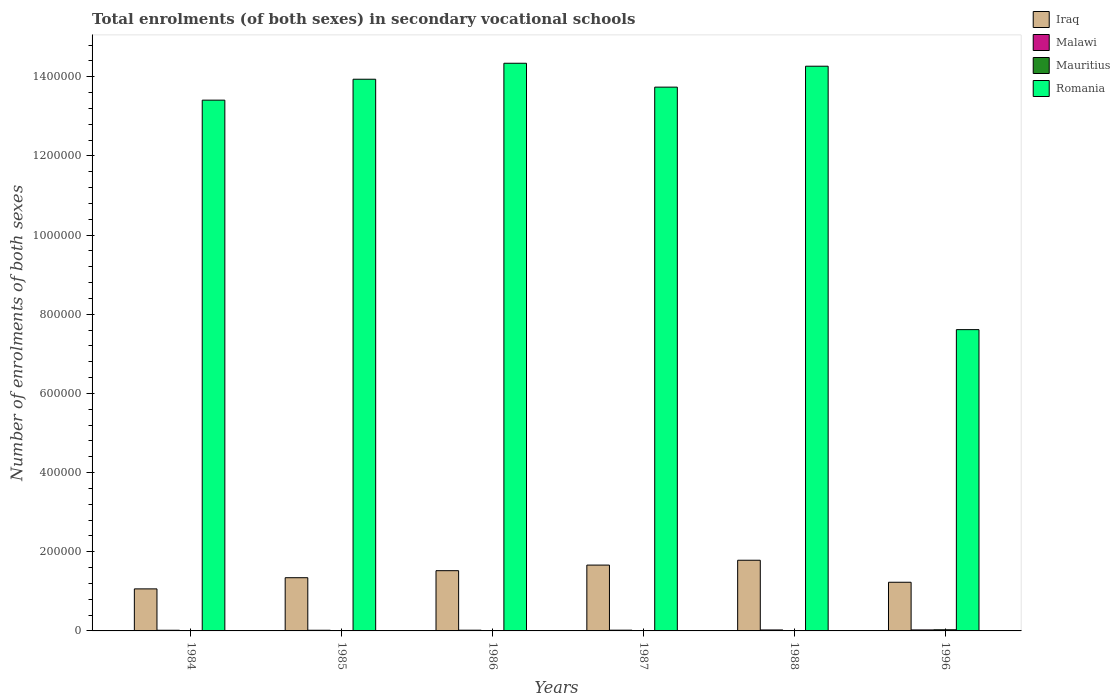How many groups of bars are there?
Your response must be concise. 6. Are the number of bars on each tick of the X-axis equal?
Ensure brevity in your answer.  Yes. How many bars are there on the 6th tick from the left?
Keep it short and to the point. 4. What is the number of enrolments in secondary schools in Malawi in 1985?
Provide a succinct answer. 1669. Across all years, what is the maximum number of enrolments in secondary schools in Malawi?
Provide a succinct answer. 2525. Across all years, what is the minimum number of enrolments in secondary schools in Malawi?
Offer a terse response. 1669. In which year was the number of enrolments in secondary schools in Iraq maximum?
Give a very brief answer. 1988. In which year was the number of enrolments in secondary schools in Malawi minimum?
Keep it short and to the point. 1985. What is the total number of enrolments in secondary schools in Romania in the graph?
Offer a terse response. 7.73e+06. What is the difference between the number of enrolments in secondary schools in Mauritius in 1986 and the number of enrolments in secondary schools in Malawi in 1984?
Keep it short and to the point. -726. What is the average number of enrolments in secondary schools in Romania per year?
Give a very brief answer. 1.29e+06. In the year 1988, what is the difference between the number of enrolments in secondary schools in Malawi and number of enrolments in secondary schools in Romania?
Your answer should be very brief. -1.42e+06. What is the ratio of the number of enrolments in secondary schools in Mauritius in 1988 to that in 1996?
Give a very brief answer. 0.33. Is the number of enrolments in secondary schools in Romania in 1987 less than that in 1988?
Keep it short and to the point. Yes. What is the difference between the highest and the second highest number of enrolments in secondary schools in Mauritius?
Make the answer very short. 1933. What is the difference between the highest and the lowest number of enrolments in secondary schools in Iraq?
Keep it short and to the point. 7.24e+04. What does the 3rd bar from the left in 1985 represents?
Make the answer very short. Mauritius. What does the 3rd bar from the right in 1984 represents?
Ensure brevity in your answer.  Malawi. Does the graph contain any zero values?
Give a very brief answer. No. Does the graph contain grids?
Offer a very short reply. No. What is the title of the graph?
Provide a succinct answer. Total enrolments (of both sexes) in secondary vocational schools. Does "Cayman Islands" appear as one of the legend labels in the graph?
Give a very brief answer. No. What is the label or title of the Y-axis?
Ensure brevity in your answer.  Number of enrolments of both sexes. What is the Number of enrolments of both sexes in Iraq in 1984?
Provide a succinct answer. 1.06e+05. What is the Number of enrolments of both sexes of Malawi in 1984?
Provide a succinct answer. 1688. What is the Number of enrolments of both sexes of Mauritius in 1984?
Make the answer very short. 834. What is the Number of enrolments of both sexes of Romania in 1984?
Offer a very short reply. 1.34e+06. What is the Number of enrolments of both sexes of Iraq in 1985?
Offer a very short reply. 1.34e+05. What is the Number of enrolments of both sexes of Malawi in 1985?
Your answer should be very brief. 1669. What is the Number of enrolments of both sexes of Mauritius in 1985?
Your answer should be compact. 865. What is the Number of enrolments of both sexes of Romania in 1985?
Provide a succinct answer. 1.39e+06. What is the Number of enrolments of both sexes of Iraq in 1986?
Make the answer very short. 1.52e+05. What is the Number of enrolments of both sexes in Malawi in 1986?
Offer a very short reply. 1818. What is the Number of enrolments of both sexes in Mauritius in 1986?
Give a very brief answer. 962. What is the Number of enrolments of both sexes in Romania in 1986?
Your answer should be very brief. 1.43e+06. What is the Number of enrolments of both sexes of Iraq in 1987?
Ensure brevity in your answer.  1.66e+05. What is the Number of enrolments of both sexes in Malawi in 1987?
Your response must be concise. 1860. What is the Number of enrolments of both sexes of Mauritius in 1987?
Your response must be concise. 863. What is the Number of enrolments of both sexes of Romania in 1987?
Your answer should be compact. 1.37e+06. What is the Number of enrolments of both sexes in Iraq in 1988?
Offer a terse response. 1.79e+05. What is the Number of enrolments of both sexes in Malawi in 1988?
Your response must be concise. 2427. What is the Number of enrolments of both sexes in Mauritius in 1988?
Provide a short and direct response. 952. What is the Number of enrolments of both sexes in Romania in 1988?
Provide a short and direct response. 1.43e+06. What is the Number of enrolments of both sexes of Iraq in 1996?
Provide a succinct answer. 1.23e+05. What is the Number of enrolments of both sexes in Malawi in 1996?
Your answer should be very brief. 2525. What is the Number of enrolments of both sexes of Mauritius in 1996?
Your answer should be compact. 2895. What is the Number of enrolments of both sexes in Romania in 1996?
Offer a very short reply. 7.61e+05. Across all years, what is the maximum Number of enrolments of both sexes of Iraq?
Keep it short and to the point. 1.79e+05. Across all years, what is the maximum Number of enrolments of both sexes of Malawi?
Make the answer very short. 2525. Across all years, what is the maximum Number of enrolments of both sexes in Mauritius?
Provide a succinct answer. 2895. Across all years, what is the maximum Number of enrolments of both sexes of Romania?
Your answer should be compact. 1.43e+06. Across all years, what is the minimum Number of enrolments of both sexes in Iraq?
Offer a very short reply. 1.06e+05. Across all years, what is the minimum Number of enrolments of both sexes in Malawi?
Your response must be concise. 1669. Across all years, what is the minimum Number of enrolments of both sexes in Mauritius?
Your response must be concise. 834. Across all years, what is the minimum Number of enrolments of both sexes in Romania?
Your answer should be very brief. 7.61e+05. What is the total Number of enrolments of both sexes in Iraq in the graph?
Provide a succinct answer. 8.61e+05. What is the total Number of enrolments of both sexes of Malawi in the graph?
Your answer should be very brief. 1.20e+04. What is the total Number of enrolments of both sexes of Mauritius in the graph?
Offer a terse response. 7371. What is the total Number of enrolments of both sexes in Romania in the graph?
Offer a very short reply. 7.73e+06. What is the difference between the Number of enrolments of both sexes in Iraq in 1984 and that in 1985?
Your answer should be very brief. -2.82e+04. What is the difference between the Number of enrolments of both sexes in Malawi in 1984 and that in 1985?
Ensure brevity in your answer.  19. What is the difference between the Number of enrolments of both sexes in Mauritius in 1984 and that in 1985?
Keep it short and to the point. -31. What is the difference between the Number of enrolments of both sexes in Romania in 1984 and that in 1985?
Keep it short and to the point. -5.29e+04. What is the difference between the Number of enrolments of both sexes in Iraq in 1984 and that in 1986?
Ensure brevity in your answer.  -4.60e+04. What is the difference between the Number of enrolments of both sexes of Malawi in 1984 and that in 1986?
Offer a terse response. -130. What is the difference between the Number of enrolments of both sexes of Mauritius in 1984 and that in 1986?
Your response must be concise. -128. What is the difference between the Number of enrolments of both sexes of Romania in 1984 and that in 1986?
Give a very brief answer. -9.32e+04. What is the difference between the Number of enrolments of both sexes of Iraq in 1984 and that in 1987?
Your answer should be compact. -6.01e+04. What is the difference between the Number of enrolments of both sexes in Malawi in 1984 and that in 1987?
Offer a terse response. -172. What is the difference between the Number of enrolments of both sexes of Romania in 1984 and that in 1987?
Provide a short and direct response. -3.29e+04. What is the difference between the Number of enrolments of both sexes of Iraq in 1984 and that in 1988?
Your answer should be very brief. -7.24e+04. What is the difference between the Number of enrolments of both sexes of Malawi in 1984 and that in 1988?
Provide a short and direct response. -739. What is the difference between the Number of enrolments of both sexes of Mauritius in 1984 and that in 1988?
Provide a short and direct response. -118. What is the difference between the Number of enrolments of both sexes of Romania in 1984 and that in 1988?
Your answer should be very brief. -8.58e+04. What is the difference between the Number of enrolments of both sexes in Iraq in 1984 and that in 1996?
Ensure brevity in your answer.  -1.67e+04. What is the difference between the Number of enrolments of both sexes in Malawi in 1984 and that in 1996?
Offer a very short reply. -837. What is the difference between the Number of enrolments of both sexes of Mauritius in 1984 and that in 1996?
Provide a succinct answer. -2061. What is the difference between the Number of enrolments of both sexes of Romania in 1984 and that in 1996?
Offer a terse response. 5.80e+05. What is the difference between the Number of enrolments of both sexes in Iraq in 1985 and that in 1986?
Offer a very short reply. -1.78e+04. What is the difference between the Number of enrolments of both sexes of Malawi in 1985 and that in 1986?
Your answer should be very brief. -149. What is the difference between the Number of enrolments of both sexes in Mauritius in 1985 and that in 1986?
Your response must be concise. -97. What is the difference between the Number of enrolments of both sexes of Romania in 1985 and that in 1986?
Provide a short and direct response. -4.03e+04. What is the difference between the Number of enrolments of both sexes in Iraq in 1985 and that in 1987?
Make the answer very short. -3.19e+04. What is the difference between the Number of enrolments of both sexes of Malawi in 1985 and that in 1987?
Offer a very short reply. -191. What is the difference between the Number of enrolments of both sexes in Mauritius in 1985 and that in 1987?
Your response must be concise. 2. What is the difference between the Number of enrolments of both sexes of Romania in 1985 and that in 1987?
Make the answer very short. 2.00e+04. What is the difference between the Number of enrolments of both sexes in Iraq in 1985 and that in 1988?
Your answer should be very brief. -4.41e+04. What is the difference between the Number of enrolments of both sexes in Malawi in 1985 and that in 1988?
Your response must be concise. -758. What is the difference between the Number of enrolments of both sexes of Mauritius in 1985 and that in 1988?
Provide a short and direct response. -87. What is the difference between the Number of enrolments of both sexes of Romania in 1985 and that in 1988?
Ensure brevity in your answer.  -3.29e+04. What is the difference between the Number of enrolments of both sexes in Iraq in 1985 and that in 1996?
Keep it short and to the point. 1.15e+04. What is the difference between the Number of enrolments of both sexes of Malawi in 1985 and that in 1996?
Offer a terse response. -856. What is the difference between the Number of enrolments of both sexes in Mauritius in 1985 and that in 1996?
Make the answer very short. -2030. What is the difference between the Number of enrolments of both sexes of Romania in 1985 and that in 1996?
Your answer should be very brief. 6.33e+05. What is the difference between the Number of enrolments of both sexes of Iraq in 1986 and that in 1987?
Your response must be concise. -1.41e+04. What is the difference between the Number of enrolments of both sexes of Malawi in 1986 and that in 1987?
Your response must be concise. -42. What is the difference between the Number of enrolments of both sexes in Mauritius in 1986 and that in 1987?
Ensure brevity in your answer.  99. What is the difference between the Number of enrolments of both sexes of Romania in 1986 and that in 1987?
Ensure brevity in your answer.  6.03e+04. What is the difference between the Number of enrolments of both sexes of Iraq in 1986 and that in 1988?
Make the answer very short. -2.64e+04. What is the difference between the Number of enrolments of both sexes of Malawi in 1986 and that in 1988?
Provide a short and direct response. -609. What is the difference between the Number of enrolments of both sexes in Mauritius in 1986 and that in 1988?
Offer a terse response. 10. What is the difference between the Number of enrolments of both sexes of Romania in 1986 and that in 1988?
Your answer should be compact. 7461. What is the difference between the Number of enrolments of both sexes in Iraq in 1986 and that in 1996?
Give a very brief answer. 2.93e+04. What is the difference between the Number of enrolments of both sexes of Malawi in 1986 and that in 1996?
Ensure brevity in your answer.  -707. What is the difference between the Number of enrolments of both sexes in Mauritius in 1986 and that in 1996?
Keep it short and to the point. -1933. What is the difference between the Number of enrolments of both sexes of Romania in 1986 and that in 1996?
Keep it short and to the point. 6.73e+05. What is the difference between the Number of enrolments of both sexes in Iraq in 1987 and that in 1988?
Offer a very short reply. -1.22e+04. What is the difference between the Number of enrolments of both sexes of Malawi in 1987 and that in 1988?
Offer a terse response. -567. What is the difference between the Number of enrolments of both sexes in Mauritius in 1987 and that in 1988?
Your answer should be compact. -89. What is the difference between the Number of enrolments of both sexes of Romania in 1987 and that in 1988?
Give a very brief answer. -5.28e+04. What is the difference between the Number of enrolments of both sexes in Iraq in 1987 and that in 1996?
Provide a succinct answer. 4.34e+04. What is the difference between the Number of enrolments of both sexes of Malawi in 1987 and that in 1996?
Provide a short and direct response. -665. What is the difference between the Number of enrolments of both sexes of Mauritius in 1987 and that in 1996?
Ensure brevity in your answer.  -2032. What is the difference between the Number of enrolments of both sexes in Romania in 1987 and that in 1996?
Ensure brevity in your answer.  6.13e+05. What is the difference between the Number of enrolments of both sexes in Iraq in 1988 and that in 1996?
Keep it short and to the point. 5.56e+04. What is the difference between the Number of enrolments of both sexes of Malawi in 1988 and that in 1996?
Provide a short and direct response. -98. What is the difference between the Number of enrolments of both sexes in Mauritius in 1988 and that in 1996?
Keep it short and to the point. -1943. What is the difference between the Number of enrolments of both sexes of Romania in 1988 and that in 1996?
Your response must be concise. 6.66e+05. What is the difference between the Number of enrolments of both sexes of Iraq in 1984 and the Number of enrolments of both sexes of Malawi in 1985?
Offer a very short reply. 1.05e+05. What is the difference between the Number of enrolments of both sexes of Iraq in 1984 and the Number of enrolments of both sexes of Mauritius in 1985?
Your answer should be very brief. 1.05e+05. What is the difference between the Number of enrolments of both sexes of Iraq in 1984 and the Number of enrolments of both sexes of Romania in 1985?
Your answer should be compact. -1.29e+06. What is the difference between the Number of enrolments of both sexes in Malawi in 1984 and the Number of enrolments of both sexes in Mauritius in 1985?
Keep it short and to the point. 823. What is the difference between the Number of enrolments of both sexes of Malawi in 1984 and the Number of enrolments of both sexes of Romania in 1985?
Keep it short and to the point. -1.39e+06. What is the difference between the Number of enrolments of both sexes of Mauritius in 1984 and the Number of enrolments of both sexes of Romania in 1985?
Your answer should be compact. -1.39e+06. What is the difference between the Number of enrolments of both sexes in Iraq in 1984 and the Number of enrolments of both sexes in Malawi in 1986?
Ensure brevity in your answer.  1.04e+05. What is the difference between the Number of enrolments of both sexes of Iraq in 1984 and the Number of enrolments of both sexes of Mauritius in 1986?
Your answer should be very brief. 1.05e+05. What is the difference between the Number of enrolments of both sexes in Iraq in 1984 and the Number of enrolments of both sexes in Romania in 1986?
Keep it short and to the point. -1.33e+06. What is the difference between the Number of enrolments of both sexes of Malawi in 1984 and the Number of enrolments of both sexes of Mauritius in 1986?
Your answer should be compact. 726. What is the difference between the Number of enrolments of both sexes of Malawi in 1984 and the Number of enrolments of both sexes of Romania in 1986?
Offer a terse response. -1.43e+06. What is the difference between the Number of enrolments of both sexes of Mauritius in 1984 and the Number of enrolments of both sexes of Romania in 1986?
Your answer should be compact. -1.43e+06. What is the difference between the Number of enrolments of both sexes of Iraq in 1984 and the Number of enrolments of both sexes of Malawi in 1987?
Offer a very short reply. 1.04e+05. What is the difference between the Number of enrolments of both sexes in Iraq in 1984 and the Number of enrolments of both sexes in Mauritius in 1987?
Ensure brevity in your answer.  1.05e+05. What is the difference between the Number of enrolments of both sexes in Iraq in 1984 and the Number of enrolments of both sexes in Romania in 1987?
Offer a terse response. -1.27e+06. What is the difference between the Number of enrolments of both sexes in Malawi in 1984 and the Number of enrolments of both sexes in Mauritius in 1987?
Your answer should be very brief. 825. What is the difference between the Number of enrolments of both sexes in Malawi in 1984 and the Number of enrolments of both sexes in Romania in 1987?
Provide a short and direct response. -1.37e+06. What is the difference between the Number of enrolments of both sexes of Mauritius in 1984 and the Number of enrolments of both sexes of Romania in 1987?
Offer a very short reply. -1.37e+06. What is the difference between the Number of enrolments of both sexes of Iraq in 1984 and the Number of enrolments of both sexes of Malawi in 1988?
Give a very brief answer. 1.04e+05. What is the difference between the Number of enrolments of both sexes in Iraq in 1984 and the Number of enrolments of both sexes in Mauritius in 1988?
Give a very brief answer. 1.05e+05. What is the difference between the Number of enrolments of both sexes in Iraq in 1984 and the Number of enrolments of both sexes in Romania in 1988?
Your answer should be compact. -1.32e+06. What is the difference between the Number of enrolments of both sexes in Malawi in 1984 and the Number of enrolments of both sexes in Mauritius in 1988?
Your response must be concise. 736. What is the difference between the Number of enrolments of both sexes in Malawi in 1984 and the Number of enrolments of both sexes in Romania in 1988?
Offer a terse response. -1.43e+06. What is the difference between the Number of enrolments of both sexes of Mauritius in 1984 and the Number of enrolments of both sexes of Romania in 1988?
Give a very brief answer. -1.43e+06. What is the difference between the Number of enrolments of both sexes of Iraq in 1984 and the Number of enrolments of both sexes of Malawi in 1996?
Provide a succinct answer. 1.04e+05. What is the difference between the Number of enrolments of both sexes in Iraq in 1984 and the Number of enrolments of both sexes in Mauritius in 1996?
Provide a succinct answer. 1.03e+05. What is the difference between the Number of enrolments of both sexes in Iraq in 1984 and the Number of enrolments of both sexes in Romania in 1996?
Make the answer very short. -6.55e+05. What is the difference between the Number of enrolments of both sexes of Malawi in 1984 and the Number of enrolments of both sexes of Mauritius in 1996?
Provide a succinct answer. -1207. What is the difference between the Number of enrolments of both sexes in Malawi in 1984 and the Number of enrolments of both sexes in Romania in 1996?
Your answer should be compact. -7.60e+05. What is the difference between the Number of enrolments of both sexes of Mauritius in 1984 and the Number of enrolments of both sexes of Romania in 1996?
Make the answer very short. -7.60e+05. What is the difference between the Number of enrolments of both sexes of Iraq in 1985 and the Number of enrolments of both sexes of Malawi in 1986?
Your response must be concise. 1.33e+05. What is the difference between the Number of enrolments of both sexes of Iraq in 1985 and the Number of enrolments of both sexes of Mauritius in 1986?
Your answer should be compact. 1.33e+05. What is the difference between the Number of enrolments of both sexes in Iraq in 1985 and the Number of enrolments of both sexes in Romania in 1986?
Offer a very short reply. -1.30e+06. What is the difference between the Number of enrolments of both sexes in Malawi in 1985 and the Number of enrolments of both sexes in Mauritius in 1986?
Ensure brevity in your answer.  707. What is the difference between the Number of enrolments of both sexes in Malawi in 1985 and the Number of enrolments of both sexes in Romania in 1986?
Your answer should be compact. -1.43e+06. What is the difference between the Number of enrolments of both sexes in Mauritius in 1985 and the Number of enrolments of both sexes in Romania in 1986?
Your answer should be compact. -1.43e+06. What is the difference between the Number of enrolments of both sexes of Iraq in 1985 and the Number of enrolments of both sexes of Malawi in 1987?
Provide a short and direct response. 1.33e+05. What is the difference between the Number of enrolments of both sexes in Iraq in 1985 and the Number of enrolments of both sexes in Mauritius in 1987?
Offer a very short reply. 1.34e+05. What is the difference between the Number of enrolments of both sexes in Iraq in 1985 and the Number of enrolments of both sexes in Romania in 1987?
Offer a very short reply. -1.24e+06. What is the difference between the Number of enrolments of both sexes in Malawi in 1985 and the Number of enrolments of both sexes in Mauritius in 1987?
Provide a succinct answer. 806. What is the difference between the Number of enrolments of both sexes in Malawi in 1985 and the Number of enrolments of both sexes in Romania in 1987?
Give a very brief answer. -1.37e+06. What is the difference between the Number of enrolments of both sexes of Mauritius in 1985 and the Number of enrolments of both sexes of Romania in 1987?
Your response must be concise. -1.37e+06. What is the difference between the Number of enrolments of both sexes in Iraq in 1985 and the Number of enrolments of both sexes in Malawi in 1988?
Your response must be concise. 1.32e+05. What is the difference between the Number of enrolments of both sexes of Iraq in 1985 and the Number of enrolments of both sexes of Mauritius in 1988?
Give a very brief answer. 1.33e+05. What is the difference between the Number of enrolments of both sexes in Iraq in 1985 and the Number of enrolments of both sexes in Romania in 1988?
Keep it short and to the point. -1.29e+06. What is the difference between the Number of enrolments of both sexes of Malawi in 1985 and the Number of enrolments of both sexes of Mauritius in 1988?
Ensure brevity in your answer.  717. What is the difference between the Number of enrolments of both sexes of Malawi in 1985 and the Number of enrolments of both sexes of Romania in 1988?
Your answer should be very brief. -1.43e+06. What is the difference between the Number of enrolments of both sexes in Mauritius in 1985 and the Number of enrolments of both sexes in Romania in 1988?
Make the answer very short. -1.43e+06. What is the difference between the Number of enrolments of both sexes of Iraq in 1985 and the Number of enrolments of both sexes of Malawi in 1996?
Your answer should be very brief. 1.32e+05. What is the difference between the Number of enrolments of both sexes in Iraq in 1985 and the Number of enrolments of both sexes in Mauritius in 1996?
Offer a very short reply. 1.32e+05. What is the difference between the Number of enrolments of both sexes of Iraq in 1985 and the Number of enrolments of both sexes of Romania in 1996?
Your answer should be compact. -6.27e+05. What is the difference between the Number of enrolments of both sexes in Malawi in 1985 and the Number of enrolments of both sexes in Mauritius in 1996?
Give a very brief answer. -1226. What is the difference between the Number of enrolments of both sexes in Malawi in 1985 and the Number of enrolments of both sexes in Romania in 1996?
Offer a terse response. -7.60e+05. What is the difference between the Number of enrolments of both sexes of Mauritius in 1985 and the Number of enrolments of both sexes of Romania in 1996?
Your answer should be compact. -7.60e+05. What is the difference between the Number of enrolments of both sexes of Iraq in 1986 and the Number of enrolments of both sexes of Malawi in 1987?
Your answer should be compact. 1.50e+05. What is the difference between the Number of enrolments of both sexes in Iraq in 1986 and the Number of enrolments of both sexes in Mauritius in 1987?
Offer a terse response. 1.51e+05. What is the difference between the Number of enrolments of both sexes in Iraq in 1986 and the Number of enrolments of both sexes in Romania in 1987?
Provide a succinct answer. -1.22e+06. What is the difference between the Number of enrolments of both sexes of Malawi in 1986 and the Number of enrolments of both sexes of Mauritius in 1987?
Provide a short and direct response. 955. What is the difference between the Number of enrolments of both sexes of Malawi in 1986 and the Number of enrolments of both sexes of Romania in 1987?
Ensure brevity in your answer.  -1.37e+06. What is the difference between the Number of enrolments of both sexes of Mauritius in 1986 and the Number of enrolments of both sexes of Romania in 1987?
Make the answer very short. -1.37e+06. What is the difference between the Number of enrolments of both sexes of Iraq in 1986 and the Number of enrolments of both sexes of Malawi in 1988?
Your answer should be very brief. 1.50e+05. What is the difference between the Number of enrolments of both sexes of Iraq in 1986 and the Number of enrolments of both sexes of Mauritius in 1988?
Keep it short and to the point. 1.51e+05. What is the difference between the Number of enrolments of both sexes of Iraq in 1986 and the Number of enrolments of both sexes of Romania in 1988?
Give a very brief answer. -1.27e+06. What is the difference between the Number of enrolments of both sexes in Malawi in 1986 and the Number of enrolments of both sexes in Mauritius in 1988?
Offer a very short reply. 866. What is the difference between the Number of enrolments of both sexes in Malawi in 1986 and the Number of enrolments of both sexes in Romania in 1988?
Your answer should be compact. -1.43e+06. What is the difference between the Number of enrolments of both sexes of Mauritius in 1986 and the Number of enrolments of both sexes of Romania in 1988?
Offer a terse response. -1.43e+06. What is the difference between the Number of enrolments of both sexes of Iraq in 1986 and the Number of enrolments of both sexes of Malawi in 1996?
Provide a short and direct response. 1.50e+05. What is the difference between the Number of enrolments of both sexes in Iraq in 1986 and the Number of enrolments of both sexes in Mauritius in 1996?
Offer a very short reply. 1.49e+05. What is the difference between the Number of enrolments of both sexes of Iraq in 1986 and the Number of enrolments of both sexes of Romania in 1996?
Keep it short and to the point. -6.09e+05. What is the difference between the Number of enrolments of both sexes of Malawi in 1986 and the Number of enrolments of both sexes of Mauritius in 1996?
Provide a succinct answer. -1077. What is the difference between the Number of enrolments of both sexes in Malawi in 1986 and the Number of enrolments of both sexes in Romania in 1996?
Make the answer very short. -7.59e+05. What is the difference between the Number of enrolments of both sexes in Mauritius in 1986 and the Number of enrolments of both sexes in Romania in 1996?
Ensure brevity in your answer.  -7.60e+05. What is the difference between the Number of enrolments of both sexes of Iraq in 1987 and the Number of enrolments of both sexes of Malawi in 1988?
Ensure brevity in your answer.  1.64e+05. What is the difference between the Number of enrolments of both sexes in Iraq in 1987 and the Number of enrolments of both sexes in Mauritius in 1988?
Your answer should be very brief. 1.65e+05. What is the difference between the Number of enrolments of both sexes of Iraq in 1987 and the Number of enrolments of both sexes of Romania in 1988?
Your answer should be compact. -1.26e+06. What is the difference between the Number of enrolments of both sexes in Malawi in 1987 and the Number of enrolments of both sexes in Mauritius in 1988?
Provide a short and direct response. 908. What is the difference between the Number of enrolments of both sexes of Malawi in 1987 and the Number of enrolments of both sexes of Romania in 1988?
Your response must be concise. -1.42e+06. What is the difference between the Number of enrolments of both sexes of Mauritius in 1987 and the Number of enrolments of both sexes of Romania in 1988?
Give a very brief answer. -1.43e+06. What is the difference between the Number of enrolments of both sexes in Iraq in 1987 and the Number of enrolments of both sexes in Malawi in 1996?
Your answer should be compact. 1.64e+05. What is the difference between the Number of enrolments of both sexes in Iraq in 1987 and the Number of enrolments of both sexes in Mauritius in 1996?
Give a very brief answer. 1.63e+05. What is the difference between the Number of enrolments of both sexes of Iraq in 1987 and the Number of enrolments of both sexes of Romania in 1996?
Your answer should be compact. -5.95e+05. What is the difference between the Number of enrolments of both sexes of Malawi in 1987 and the Number of enrolments of both sexes of Mauritius in 1996?
Give a very brief answer. -1035. What is the difference between the Number of enrolments of both sexes in Malawi in 1987 and the Number of enrolments of both sexes in Romania in 1996?
Ensure brevity in your answer.  -7.59e+05. What is the difference between the Number of enrolments of both sexes of Mauritius in 1987 and the Number of enrolments of both sexes of Romania in 1996?
Keep it short and to the point. -7.60e+05. What is the difference between the Number of enrolments of both sexes of Iraq in 1988 and the Number of enrolments of both sexes of Malawi in 1996?
Offer a very short reply. 1.76e+05. What is the difference between the Number of enrolments of both sexes of Iraq in 1988 and the Number of enrolments of both sexes of Mauritius in 1996?
Keep it short and to the point. 1.76e+05. What is the difference between the Number of enrolments of both sexes of Iraq in 1988 and the Number of enrolments of both sexes of Romania in 1996?
Make the answer very short. -5.83e+05. What is the difference between the Number of enrolments of both sexes of Malawi in 1988 and the Number of enrolments of both sexes of Mauritius in 1996?
Give a very brief answer. -468. What is the difference between the Number of enrolments of both sexes in Malawi in 1988 and the Number of enrolments of both sexes in Romania in 1996?
Offer a very short reply. -7.59e+05. What is the difference between the Number of enrolments of both sexes of Mauritius in 1988 and the Number of enrolments of both sexes of Romania in 1996?
Provide a short and direct response. -7.60e+05. What is the average Number of enrolments of both sexes in Iraq per year?
Make the answer very short. 1.43e+05. What is the average Number of enrolments of both sexes of Malawi per year?
Your answer should be compact. 1997.83. What is the average Number of enrolments of both sexes of Mauritius per year?
Give a very brief answer. 1228.5. What is the average Number of enrolments of both sexes of Romania per year?
Provide a short and direct response. 1.29e+06. In the year 1984, what is the difference between the Number of enrolments of both sexes in Iraq and Number of enrolments of both sexes in Malawi?
Give a very brief answer. 1.05e+05. In the year 1984, what is the difference between the Number of enrolments of both sexes of Iraq and Number of enrolments of both sexes of Mauritius?
Make the answer very short. 1.05e+05. In the year 1984, what is the difference between the Number of enrolments of both sexes of Iraq and Number of enrolments of both sexes of Romania?
Keep it short and to the point. -1.23e+06. In the year 1984, what is the difference between the Number of enrolments of both sexes of Malawi and Number of enrolments of both sexes of Mauritius?
Provide a succinct answer. 854. In the year 1984, what is the difference between the Number of enrolments of both sexes in Malawi and Number of enrolments of both sexes in Romania?
Your answer should be very brief. -1.34e+06. In the year 1984, what is the difference between the Number of enrolments of both sexes in Mauritius and Number of enrolments of both sexes in Romania?
Offer a very short reply. -1.34e+06. In the year 1985, what is the difference between the Number of enrolments of both sexes in Iraq and Number of enrolments of both sexes in Malawi?
Make the answer very short. 1.33e+05. In the year 1985, what is the difference between the Number of enrolments of both sexes in Iraq and Number of enrolments of both sexes in Mauritius?
Give a very brief answer. 1.34e+05. In the year 1985, what is the difference between the Number of enrolments of both sexes in Iraq and Number of enrolments of both sexes in Romania?
Ensure brevity in your answer.  -1.26e+06. In the year 1985, what is the difference between the Number of enrolments of both sexes in Malawi and Number of enrolments of both sexes in Mauritius?
Offer a terse response. 804. In the year 1985, what is the difference between the Number of enrolments of both sexes of Malawi and Number of enrolments of both sexes of Romania?
Your answer should be compact. -1.39e+06. In the year 1985, what is the difference between the Number of enrolments of both sexes of Mauritius and Number of enrolments of both sexes of Romania?
Provide a short and direct response. -1.39e+06. In the year 1986, what is the difference between the Number of enrolments of both sexes in Iraq and Number of enrolments of both sexes in Malawi?
Offer a terse response. 1.50e+05. In the year 1986, what is the difference between the Number of enrolments of both sexes of Iraq and Number of enrolments of both sexes of Mauritius?
Make the answer very short. 1.51e+05. In the year 1986, what is the difference between the Number of enrolments of both sexes of Iraq and Number of enrolments of both sexes of Romania?
Offer a very short reply. -1.28e+06. In the year 1986, what is the difference between the Number of enrolments of both sexes in Malawi and Number of enrolments of both sexes in Mauritius?
Your answer should be compact. 856. In the year 1986, what is the difference between the Number of enrolments of both sexes of Malawi and Number of enrolments of both sexes of Romania?
Offer a very short reply. -1.43e+06. In the year 1986, what is the difference between the Number of enrolments of both sexes in Mauritius and Number of enrolments of both sexes in Romania?
Your answer should be very brief. -1.43e+06. In the year 1987, what is the difference between the Number of enrolments of both sexes of Iraq and Number of enrolments of both sexes of Malawi?
Provide a short and direct response. 1.64e+05. In the year 1987, what is the difference between the Number of enrolments of both sexes in Iraq and Number of enrolments of both sexes in Mauritius?
Offer a very short reply. 1.65e+05. In the year 1987, what is the difference between the Number of enrolments of both sexes of Iraq and Number of enrolments of both sexes of Romania?
Offer a very short reply. -1.21e+06. In the year 1987, what is the difference between the Number of enrolments of both sexes of Malawi and Number of enrolments of both sexes of Mauritius?
Your response must be concise. 997. In the year 1987, what is the difference between the Number of enrolments of both sexes in Malawi and Number of enrolments of both sexes in Romania?
Your answer should be very brief. -1.37e+06. In the year 1987, what is the difference between the Number of enrolments of both sexes in Mauritius and Number of enrolments of both sexes in Romania?
Keep it short and to the point. -1.37e+06. In the year 1988, what is the difference between the Number of enrolments of both sexes of Iraq and Number of enrolments of both sexes of Malawi?
Your response must be concise. 1.76e+05. In the year 1988, what is the difference between the Number of enrolments of both sexes of Iraq and Number of enrolments of both sexes of Mauritius?
Keep it short and to the point. 1.78e+05. In the year 1988, what is the difference between the Number of enrolments of both sexes of Iraq and Number of enrolments of both sexes of Romania?
Give a very brief answer. -1.25e+06. In the year 1988, what is the difference between the Number of enrolments of both sexes of Malawi and Number of enrolments of both sexes of Mauritius?
Your answer should be compact. 1475. In the year 1988, what is the difference between the Number of enrolments of both sexes in Malawi and Number of enrolments of both sexes in Romania?
Offer a very short reply. -1.42e+06. In the year 1988, what is the difference between the Number of enrolments of both sexes in Mauritius and Number of enrolments of both sexes in Romania?
Provide a succinct answer. -1.43e+06. In the year 1996, what is the difference between the Number of enrolments of both sexes in Iraq and Number of enrolments of both sexes in Malawi?
Your response must be concise. 1.20e+05. In the year 1996, what is the difference between the Number of enrolments of both sexes in Iraq and Number of enrolments of both sexes in Mauritius?
Keep it short and to the point. 1.20e+05. In the year 1996, what is the difference between the Number of enrolments of both sexes of Iraq and Number of enrolments of both sexes of Romania?
Offer a very short reply. -6.38e+05. In the year 1996, what is the difference between the Number of enrolments of both sexes of Malawi and Number of enrolments of both sexes of Mauritius?
Ensure brevity in your answer.  -370. In the year 1996, what is the difference between the Number of enrolments of both sexes in Malawi and Number of enrolments of both sexes in Romania?
Offer a very short reply. -7.59e+05. In the year 1996, what is the difference between the Number of enrolments of both sexes of Mauritius and Number of enrolments of both sexes of Romania?
Your response must be concise. -7.58e+05. What is the ratio of the Number of enrolments of both sexes in Iraq in 1984 to that in 1985?
Ensure brevity in your answer.  0.79. What is the ratio of the Number of enrolments of both sexes in Malawi in 1984 to that in 1985?
Your answer should be very brief. 1.01. What is the ratio of the Number of enrolments of both sexes of Mauritius in 1984 to that in 1985?
Offer a terse response. 0.96. What is the ratio of the Number of enrolments of both sexes in Romania in 1984 to that in 1985?
Make the answer very short. 0.96. What is the ratio of the Number of enrolments of both sexes of Iraq in 1984 to that in 1986?
Provide a short and direct response. 0.7. What is the ratio of the Number of enrolments of both sexes in Malawi in 1984 to that in 1986?
Ensure brevity in your answer.  0.93. What is the ratio of the Number of enrolments of both sexes in Mauritius in 1984 to that in 1986?
Make the answer very short. 0.87. What is the ratio of the Number of enrolments of both sexes in Romania in 1984 to that in 1986?
Provide a succinct answer. 0.94. What is the ratio of the Number of enrolments of both sexes in Iraq in 1984 to that in 1987?
Give a very brief answer. 0.64. What is the ratio of the Number of enrolments of both sexes of Malawi in 1984 to that in 1987?
Provide a succinct answer. 0.91. What is the ratio of the Number of enrolments of both sexes in Mauritius in 1984 to that in 1987?
Offer a terse response. 0.97. What is the ratio of the Number of enrolments of both sexes in Romania in 1984 to that in 1987?
Your response must be concise. 0.98. What is the ratio of the Number of enrolments of both sexes of Iraq in 1984 to that in 1988?
Make the answer very short. 0.59. What is the ratio of the Number of enrolments of both sexes in Malawi in 1984 to that in 1988?
Ensure brevity in your answer.  0.7. What is the ratio of the Number of enrolments of both sexes in Mauritius in 1984 to that in 1988?
Offer a very short reply. 0.88. What is the ratio of the Number of enrolments of both sexes of Romania in 1984 to that in 1988?
Provide a short and direct response. 0.94. What is the ratio of the Number of enrolments of both sexes in Iraq in 1984 to that in 1996?
Offer a terse response. 0.86. What is the ratio of the Number of enrolments of both sexes of Malawi in 1984 to that in 1996?
Your response must be concise. 0.67. What is the ratio of the Number of enrolments of both sexes of Mauritius in 1984 to that in 1996?
Provide a succinct answer. 0.29. What is the ratio of the Number of enrolments of both sexes in Romania in 1984 to that in 1996?
Your response must be concise. 1.76. What is the ratio of the Number of enrolments of both sexes of Iraq in 1985 to that in 1986?
Give a very brief answer. 0.88. What is the ratio of the Number of enrolments of both sexes of Malawi in 1985 to that in 1986?
Ensure brevity in your answer.  0.92. What is the ratio of the Number of enrolments of both sexes in Mauritius in 1985 to that in 1986?
Make the answer very short. 0.9. What is the ratio of the Number of enrolments of both sexes of Romania in 1985 to that in 1986?
Give a very brief answer. 0.97. What is the ratio of the Number of enrolments of both sexes in Iraq in 1985 to that in 1987?
Give a very brief answer. 0.81. What is the ratio of the Number of enrolments of both sexes in Malawi in 1985 to that in 1987?
Provide a succinct answer. 0.9. What is the ratio of the Number of enrolments of both sexes of Mauritius in 1985 to that in 1987?
Your response must be concise. 1. What is the ratio of the Number of enrolments of both sexes of Romania in 1985 to that in 1987?
Offer a terse response. 1.01. What is the ratio of the Number of enrolments of both sexes of Iraq in 1985 to that in 1988?
Your answer should be compact. 0.75. What is the ratio of the Number of enrolments of both sexes in Malawi in 1985 to that in 1988?
Provide a succinct answer. 0.69. What is the ratio of the Number of enrolments of both sexes in Mauritius in 1985 to that in 1988?
Keep it short and to the point. 0.91. What is the ratio of the Number of enrolments of both sexes of Iraq in 1985 to that in 1996?
Provide a short and direct response. 1.09. What is the ratio of the Number of enrolments of both sexes of Malawi in 1985 to that in 1996?
Your answer should be compact. 0.66. What is the ratio of the Number of enrolments of both sexes of Mauritius in 1985 to that in 1996?
Offer a very short reply. 0.3. What is the ratio of the Number of enrolments of both sexes in Romania in 1985 to that in 1996?
Provide a succinct answer. 1.83. What is the ratio of the Number of enrolments of both sexes in Iraq in 1986 to that in 1987?
Your answer should be compact. 0.92. What is the ratio of the Number of enrolments of both sexes in Malawi in 1986 to that in 1987?
Your answer should be very brief. 0.98. What is the ratio of the Number of enrolments of both sexes of Mauritius in 1986 to that in 1987?
Your answer should be very brief. 1.11. What is the ratio of the Number of enrolments of both sexes of Romania in 1986 to that in 1987?
Offer a very short reply. 1.04. What is the ratio of the Number of enrolments of both sexes of Iraq in 1986 to that in 1988?
Provide a succinct answer. 0.85. What is the ratio of the Number of enrolments of both sexes in Malawi in 1986 to that in 1988?
Provide a succinct answer. 0.75. What is the ratio of the Number of enrolments of both sexes in Mauritius in 1986 to that in 1988?
Provide a succinct answer. 1.01. What is the ratio of the Number of enrolments of both sexes of Romania in 1986 to that in 1988?
Ensure brevity in your answer.  1.01. What is the ratio of the Number of enrolments of both sexes of Iraq in 1986 to that in 1996?
Your response must be concise. 1.24. What is the ratio of the Number of enrolments of both sexes of Malawi in 1986 to that in 1996?
Provide a succinct answer. 0.72. What is the ratio of the Number of enrolments of both sexes in Mauritius in 1986 to that in 1996?
Keep it short and to the point. 0.33. What is the ratio of the Number of enrolments of both sexes of Romania in 1986 to that in 1996?
Ensure brevity in your answer.  1.88. What is the ratio of the Number of enrolments of both sexes in Iraq in 1987 to that in 1988?
Provide a short and direct response. 0.93. What is the ratio of the Number of enrolments of both sexes of Malawi in 1987 to that in 1988?
Give a very brief answer. 0.77. What is the ratio of the Number of enrolments of both sexes of Mauritius in 1987 to that in 1988?
Your answer should be compact. 0.91. What is the ratio of the Number of enrolments of both sexes in Romania in 1987 to that in 1988?
Keep it short and to the point. 0.96. What is the ratio of the Number of enrolments of both sexes of Iraq in 1987 to that in 1996?
Ensure brevity in your answer.  1.35. What is the ratio of the Number of enrolments of both sexes of Malawi in 1987 to that in 1996?
Your answer should be very brief. 0.74. What is the ratio of the Number of enrolments of both sexes in Mauritius in 1987 to that in 1996?
Offer a terse response. 0.3. What is the ratio of the Number of enrolments of both sexes of Romania in 1987 to that in 1996?
Keep it short and to the point. 1.8. What is the ratio of the Number of enrolments of both sexes in Iraq in 1988 to that in 1996?
Offer a very short reply. 1.45. What is the ratio of the Number of enrolments of both sexes in Malawi in 1988 to that in 1996?
Provide a succinct answer. 0.96. What is the ratio of the Number of enrolments of both sexes in Mauritius in 1988 to that in 1996?
Make the answer very short. 0.33. What is the ratio of the Number of enrolments of both sexes in Romania in 1988 to that in 1996?
Make the answer very short. 1.87. What is the difference between the highest and the second highest Number of enrolments of both sexes in Iraq?
Ensure brevity in your answer.  1.22e+04. What is the difference between the highest and the second highest Number of enrolments of both sexes in Malawi?
Your response must be concise. 98. What is the difference between the highest and the second highest Number of enrolments of both sexes of Mauritius?
Your answer should be compact. 1933. What is the difference between the highest and the second highest Number of enrolments of both sexes of Romania?
Make the answer very short. 7461. What is the difference between the highest and the lowest Number of enrolments of both sexes in Iraq?
Make the answer very short. 7.24e+04. What is the difference between the highest and the lowest Number of enrolments of both sexes in Malawi?
Your answer should be compact. 856. What is the difference between the highest and the lowest Number of enrolments of both sexes of Mauritius?
Keep it short and to the point. 2061. What is the difference between the highest and the lowest Number of enrolments of both sexes in Romania?
Provide a succinct answer. 6.73e+05. 